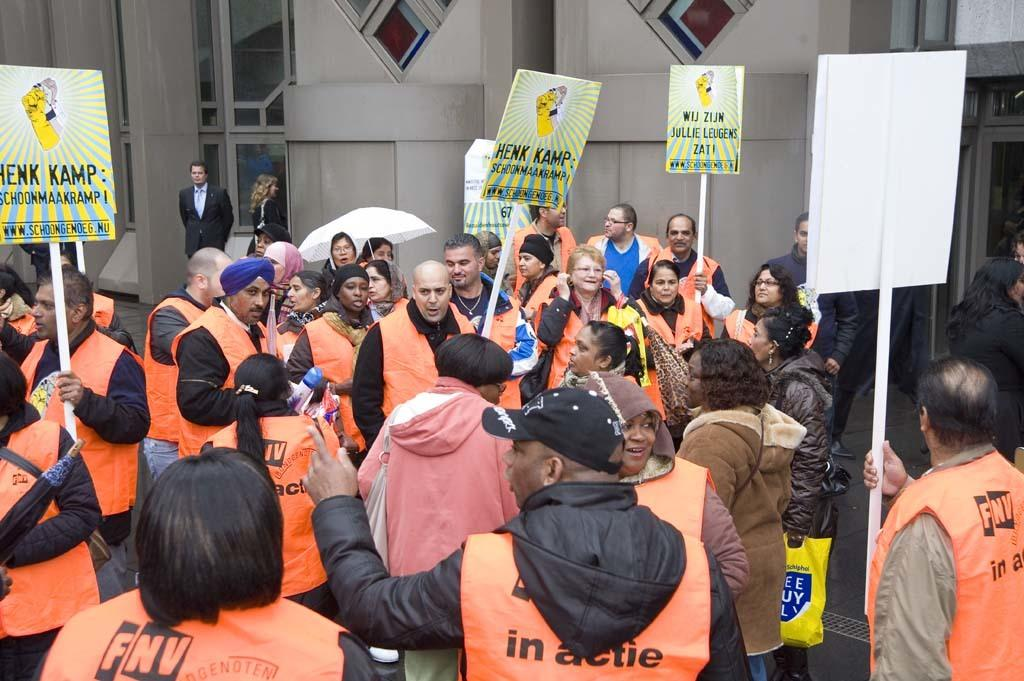<image>
Present a compact description of the photo's key features. Protester in the street gather about Henk Kamp 